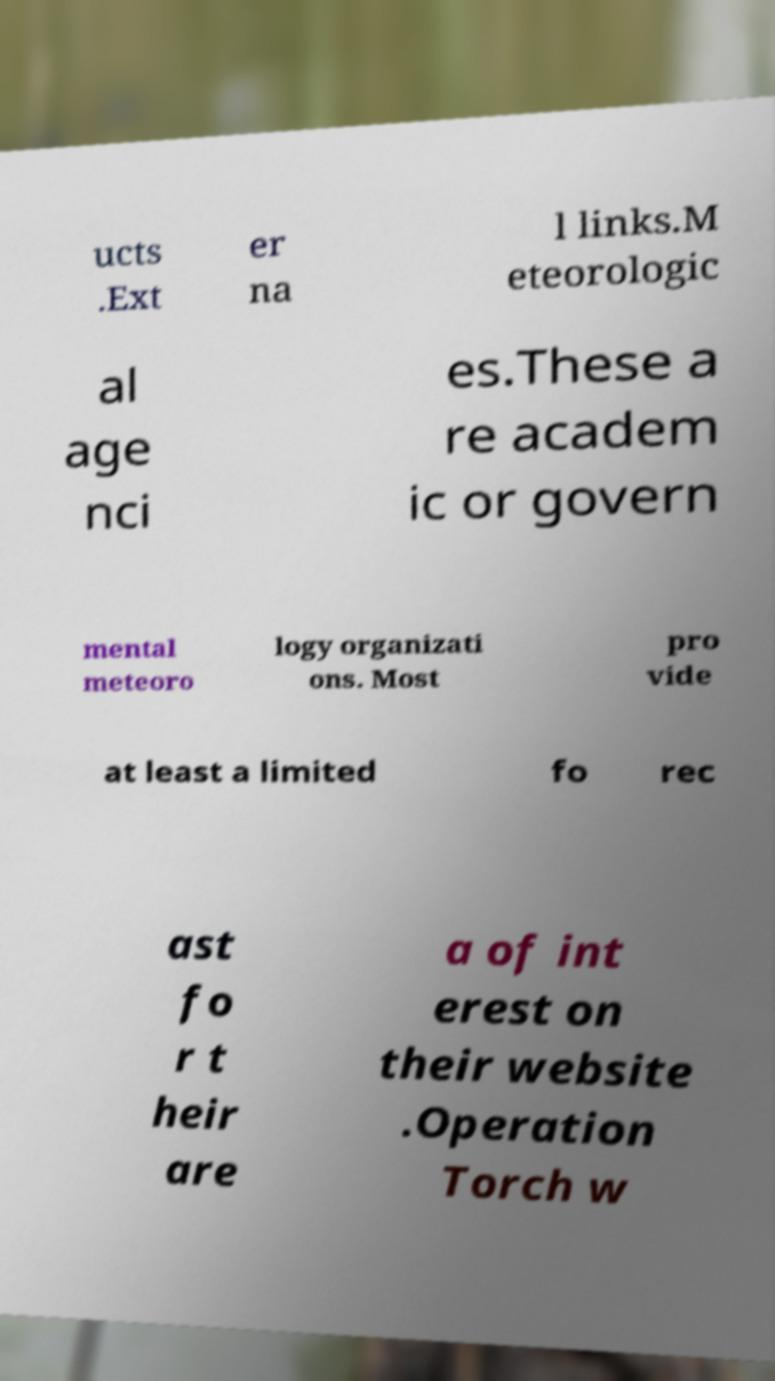Could you assist in decoding the text presented in this image and type it out clearly? ucts .Ext er na l links.M eteorologic al age nci es.These a re academ ic or govern mental meteoro logy organizati ons. Most pro vide at least a limited fo rec ast fo r t heir are a of int erest on their website .Operation Torch w 